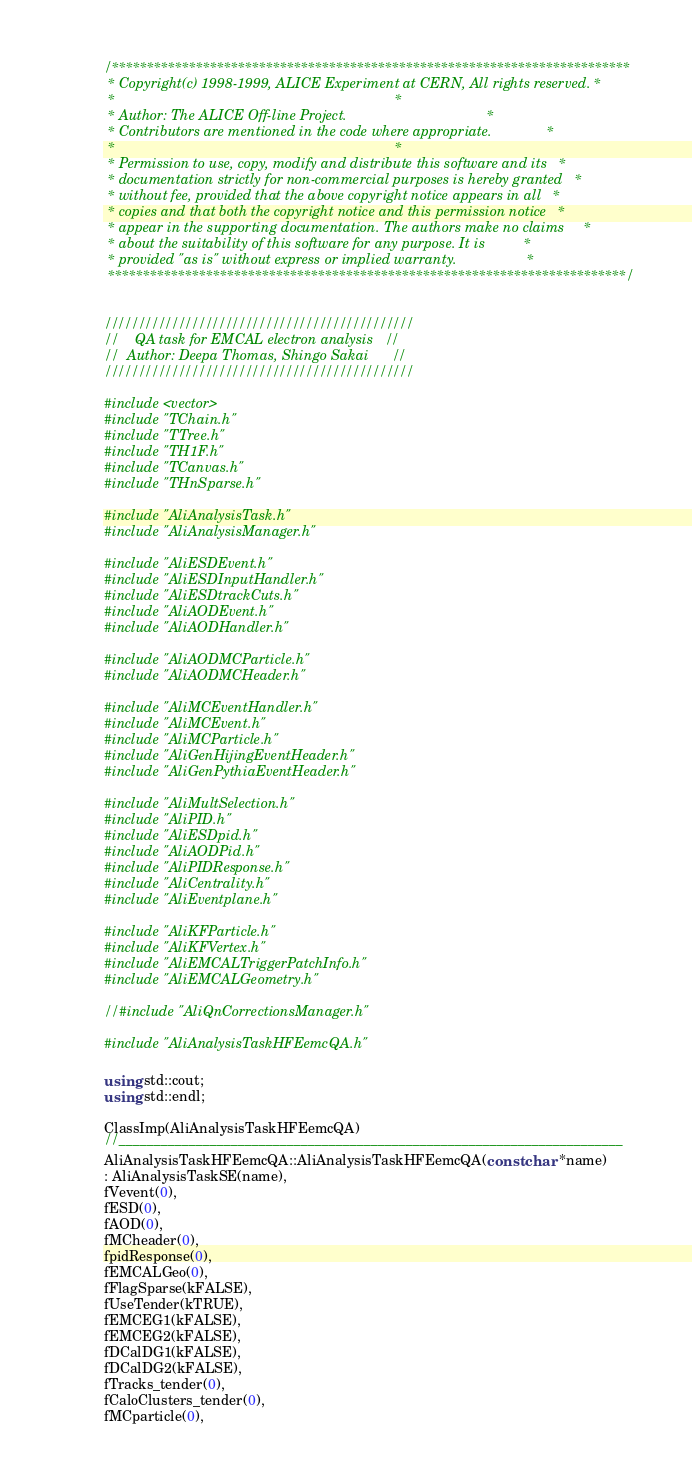Convert code to text. <code><loc_0><loc_0><loc_500><loc_500><_C++_>/**************************************************************************
 * Copyright(c) 1998-1999, ALICE Experiment at CERN, All rights reserved. *
 *                                                                        *
 * Author: The ALICE Off-line Project.                                    *
 * Contributors are mentioned in the code where appropriate.              *
 *                                                                        *
 * Permission to use, copy, modify and distribute this software and its   *
 * documentation strictly for non-commercial purposes is hereby granted   *
 * without fee, provided that the above copyright notice appears in all   *
 * copies and that both the copyright notice and this permission notice   *
 * appear in the supporting documentation. The authors make no claims     *
 * about the suitability of this software for any purpose. It is          *
 * provided "as is" without express or implied warranty.                  *
 **************************************************************************/


//////////////////////////////////////////////
//    QA task for EMCAL electron analysis   //
//  Author: Deepa Thomas, Shingo Sakai      //
//////////////////////////////////////////////

#include <vector>
#include "TChain.h"
#include "TTree.h"
#include "TH1F.h"
#include "TCanvas.h"
#include "THnSparse.h"

#include "AliAnalysisTask.h"
#include "AliAnalysisManager.h"

#include "AliESDEvent.h"
#include "AliESDInputHandler.h"
#include "AliESDtrackCuts.h"
#include "AliAODEvent.h"
#include "AliAODHandler.h"

#include "AliAODMCParticle.h"
#include "AliAODMCHeader.h"

#include "AliMCEventHandler.h"
#include "AliMCEvent.h"
#include "AliMCParticle.h"
#include "AliGenHijingEventHeader.h"
#include "AliGenPythiaEventHeader.h"

#include "AliMultSelection.h"
#include "AliPID.h"
#include "AliESDpid.h"
#include "AliAODPid.h"
#include "AliPIDResponse.h"
#include "AliCentrality.h"
#include "AliEventplane.h"

#include "AliKFParticle.h"
#include "AliKFVertex.h"
#include "AliEMCALTriggerPatchInfo.h"
#include "AliEMCALGeometry.h"

//#include "AliQnCorrectionsManager.h"

#include "AliAnalysisTaskHFEemcQA.h"

using std::cout;
using std::endl;

ClassImp(AliAnalysisTaskHFEemcQA)
//________________________________________________________________________
AliAnalysisTaskHFEemcQA::AliAnalysisTaskHFEemcQA(const char *name)
: AliAnalysisTaskSE(name),
fVevent(0),
fESD(0),
fAOD(0),
fMCheader(0),
fpidResponse(0),
fEMCALGeo(0),
fFlagSparse(kFALSE),
fUseTender(kTRUE),
fEMCEG1(kFALSE),
fEMCEG2(kFALSE),
fDCalDG1(kFALSE),
fDCalDG2(kFALSE),
fTracks_tender(0),
fCaloClusters_tender(0),
fMCparticle(0),</code> 